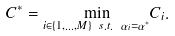Convert formula to latex. <formula><loc_0><loc_0><loc_500><loc_500>C ^ { * } = \underset { i \in \{ 1 , \dots , M \} \ s . t . \ \alpha _ { i } = \alpha ^ { * } } \min C _ { i } .</formula> 